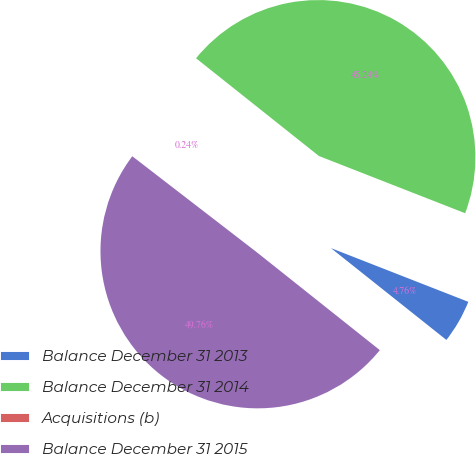Convert chart. <chart><loc_0><loc_0><loc_500><loc_500><pie_chart><fcel>Balance December 31 2013<fcel>Balance December 31 2014<fcel>Acquisitions (b)<fcel>Balance December 31 2015<nl><fcel>4.76%<fcel>45.24%<fcel>0.24%<fcel>49.76%<nl></chart> 